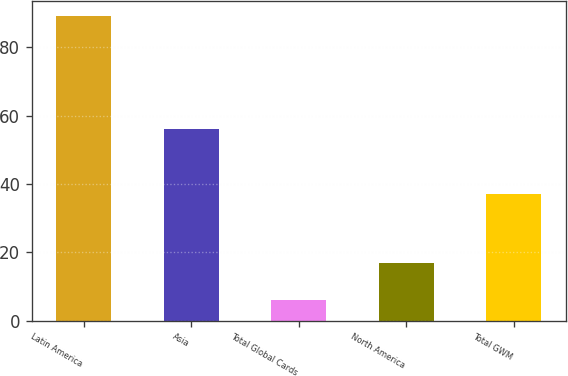<chart> <loc_0><loc_0><loc_500><loc_500><bar_chart><fcel>Latin America<fcel>Asia<fcel>Total Global Cards<fcel>North America<fcel>Total GWM<nl><fcel>89<fcel>56<fcel>6<fcel>17<fcel>37<nl></chart> 